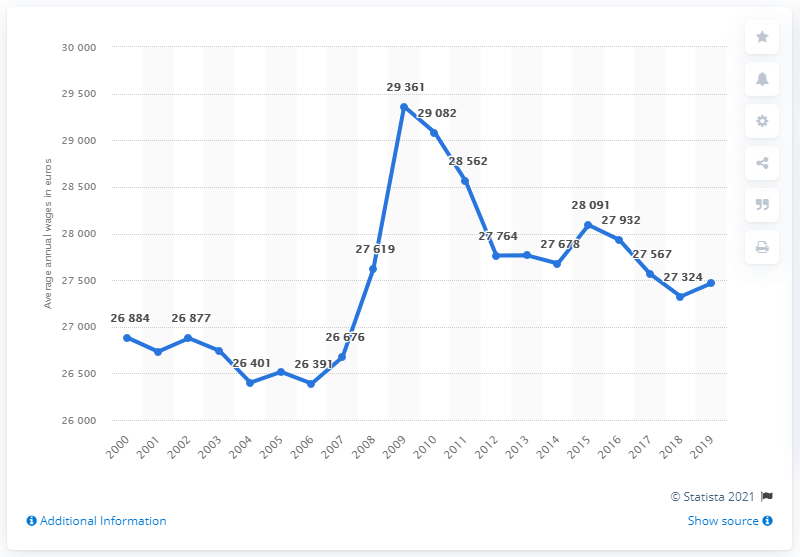Draw attention to some important aspects in this diagram. In 2012, the average annual wage in Spain was approximately 27,567 euros. The average annual wage in Spain in 2019 was approximately 27,468 euros. In 2009, the highest annual wage in Spain was 29,361 euros. 